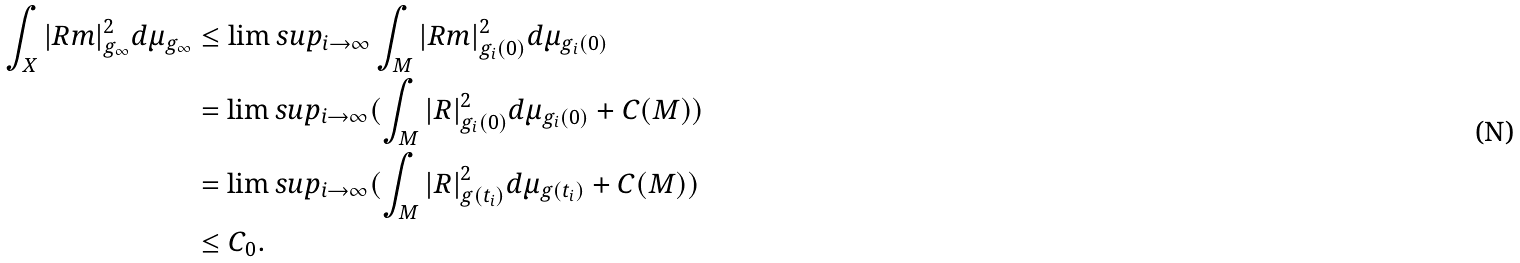<formula> <loc_0><loc_0><loc_500><loc_500>\int _ { X } | R m | _ { g _ { \infty } } ^ { 2 } d \mu _ { g _ { \infty } } & \leq \lim s u p _ { i \to \infty } \int _ { M } | R m | _ { g _ { i } ( 0 ) } ^ { 2 } d \mu _ { g _ { i } ( 0 ) } \\ & = \lim s u p _ { i \to \infty } ( \int _ { M } | R | _ { g _ { i } ( 0 ) } ^ { 2 } d \mu _ { g _ { i } ( 0 ) } + C ( M ) ) \\ & = \lim s u p _ { i \to \infty } ( \int _ { M } | R | _ { g ( t _ { i } ) } ^ { 2 } d \mu _ { g ( t _ { i } ) } + C ( M ) ) \\ & \leq C _ { 0 } .</formula> 